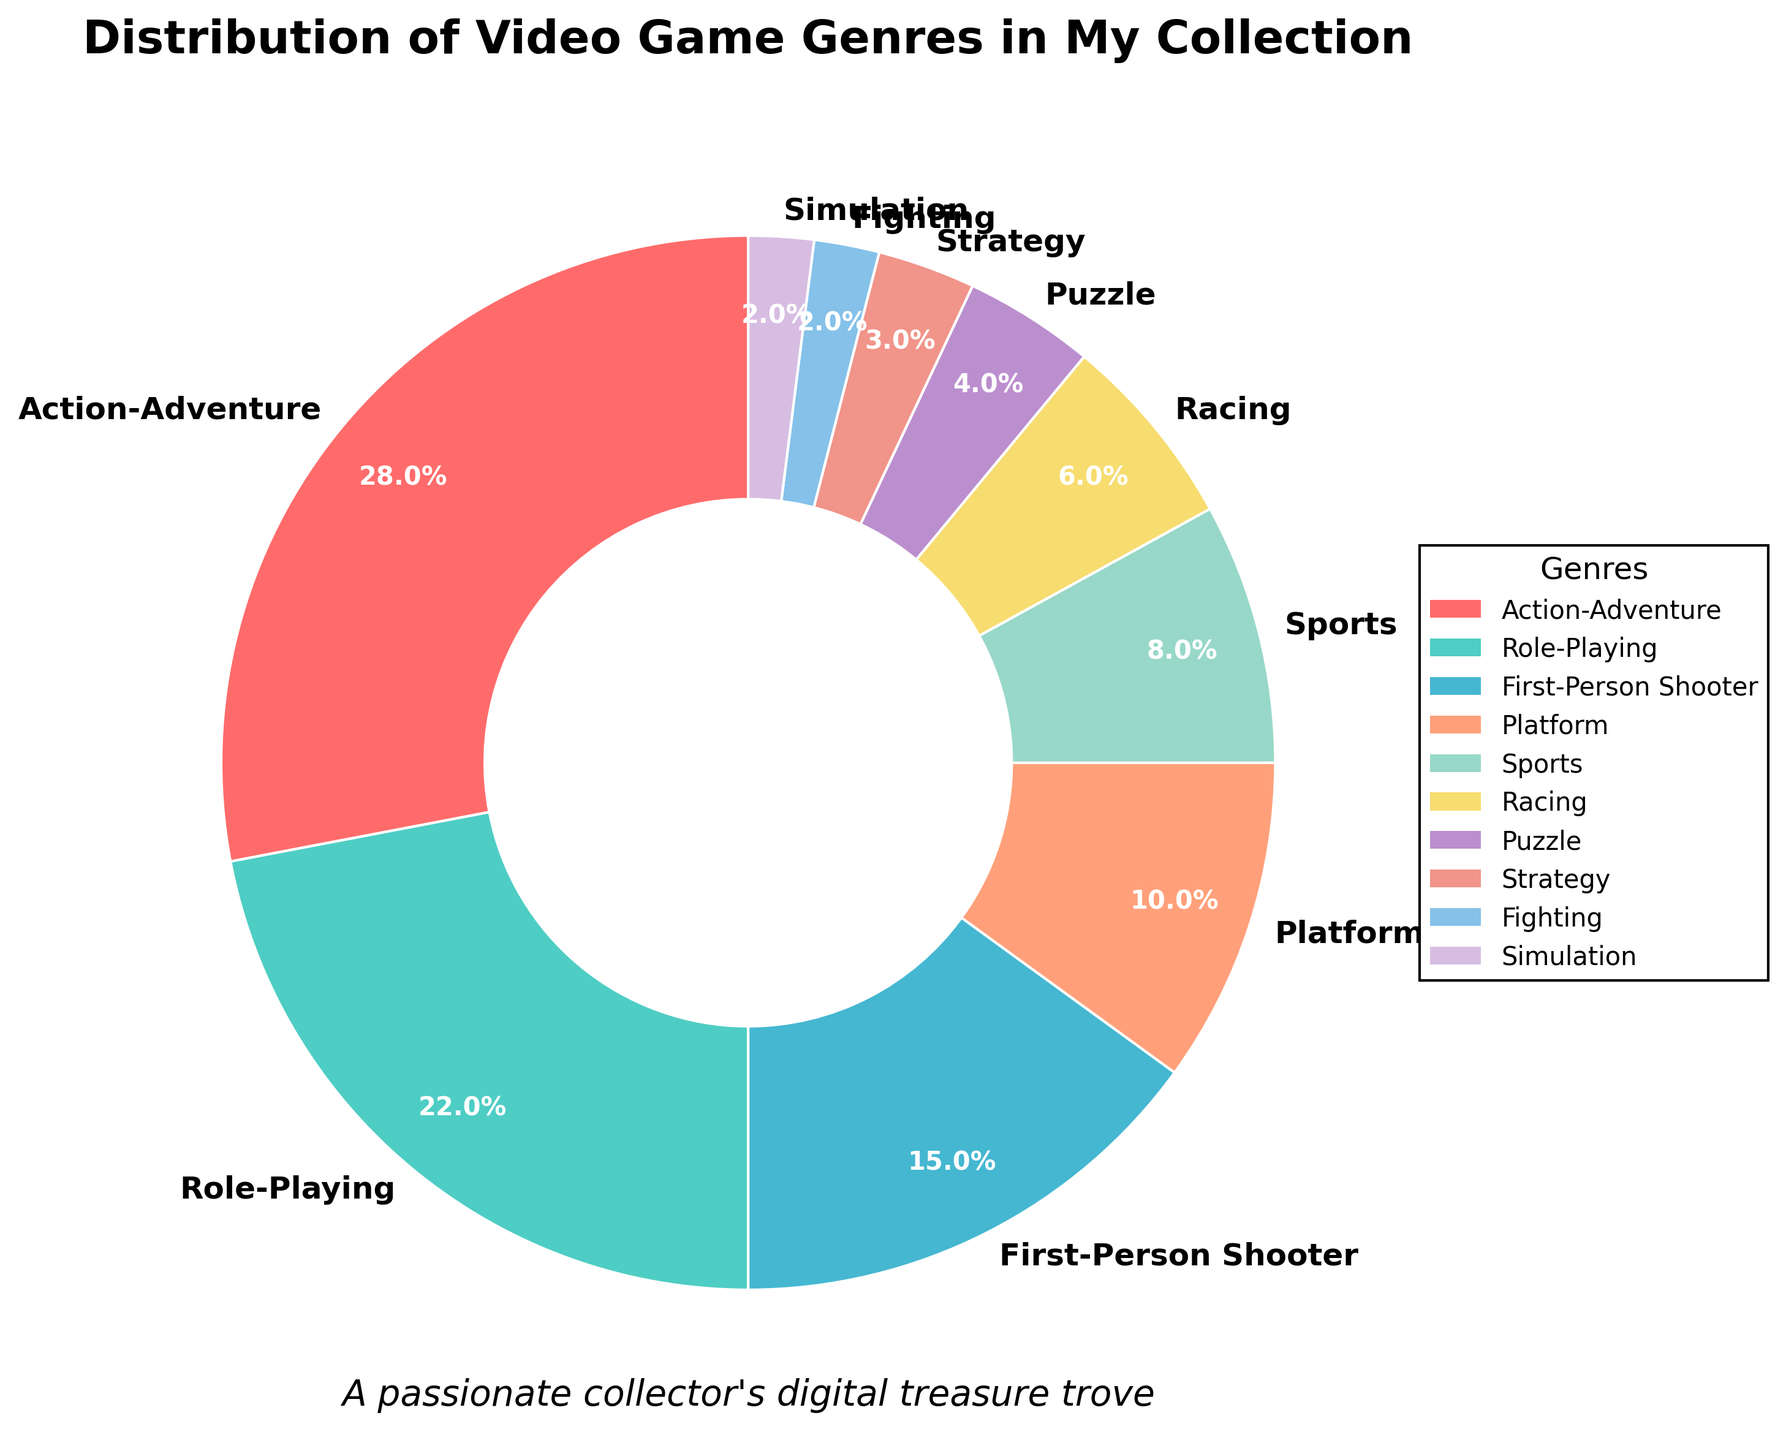What genre occupies the largest portion of the collection? The pie chart shows different segments for each genre, with the size of the segment representing its percentage. The largest segment is Action-Adventure.
Answer: Action-Adventure Which genre has the smallest share in the collection? The smallest segment of the pie chart represents the genre with the least percentage. Fighting and Simulation are the smallest, each with 2%.
Answer: Fighting and Simulation What is the combined percentage of Role-Playing and First-Person Shooter genres? To find the combined percentage, sum the percentages of Role-Playing (22%) and First-Person Shooter (15%). 22% + 15% = 37%.
Answer: 37% Are there more Sports games or Racing games in the collection? Compare the percentage segments of Sports and Racing. Sports has 8%, and Racing has 6%, so there are more Sports games.
Answer: Sports What is the total percentage of genres that have a share less than 10%? Sum the percentages of Platform (10% does not count since it's equal), Sports (8%), Racing (6%), Puzzle (4%), Strategy (3%), Fighting (2%), and Simulation (2%): 8% + 6% + 4% + 3% + 2% + 2% = 25%.
Answer: 25% By how much does Action-Adventure exceed Role-Playing in the collection? Subtract the percentage of Role-Playing (22%) from Action-Adventure (28%): 28% - 22% = 6%.
Answer: 6% Out of Puzzle, Strategy, Fighting, and Simulation, which genre has the largest share? Compare the percentages of Puzzle (4%), Strategy (3%), Fighting (2%), and Simulation (2%). Puzzle has the largest share.
Answer: Puzzle What percentage of the collection is made up of Strategy, Fighting, and Simulation games combined? Add the percentages of Strategy (3%), Fighting (2%), and Simulation (2%): 3% + 2% + 2% = 7%.
Answer: 7% Which genre segment starts the pie chart, and what is its color? The pie chart starts at 90 degrees, making the first labeled genre Action-Adventure, which appears in red.
Answer: Action-Adventure, red If you were to categorize the collection into Action-related (Action-Adventure and First-Person Shooter) and Non-Action related genres, what percentage would be Action-related? Add the percentages of Action-Adventure (28%) and First-Person Shooter (15%): 28% + 15% = 43%.
Answer: 43% 